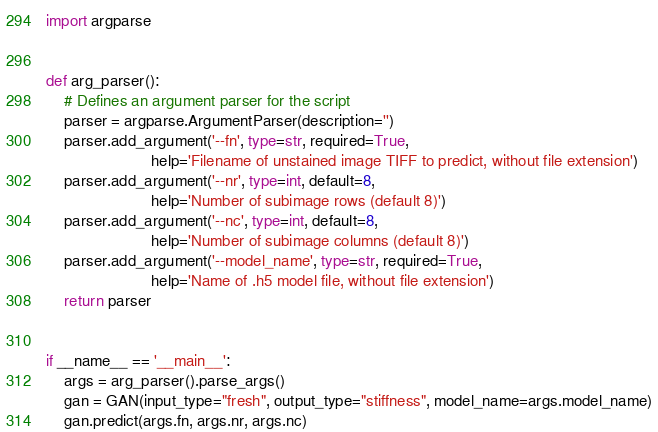Convert code to text. <code><loc_0><loc_0><loc_500><loc_500><_Python_>import argparse


def arg_parser():
	# Defines an argument parser for the script
	parser = argparse.ArgumentParser(description='')
	parser.add_argument('--fn', type=str, required=True,
						help='Filename of unstained image TIFF to predict, without file extension')
	parser.add_argument('--nr', type=int, default=8,
						help='Number of subimage rows (default 8)')
	parser.add_argument('--nc', type=int, default=8,
						help='Number of subimage columns (default 8)')
	parser.add_argument('--model_name', type=str, required=True,
						help='Name of .h5 model file, without file extension')
	return parser


if __name__ == '__main__':
	args = arg_parser().parse_args()
	gan = GAN(input_type="fresh", output_type="stiffness", model_name=args.model_name)
	gan.predict(args.fn, args.nr, args.nc)
</code> 